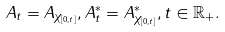<formula> <loc_0><loc_0><loc_500><loc_500>A _ { t } = A _ { \chi _ { [ 0 , t ] } } , A _ { t } ^ { * } = A _ { \chi _ { [ 0 , t ] } } ^ { * } , t \in \mathbb { R } _ { + } .</formula> 